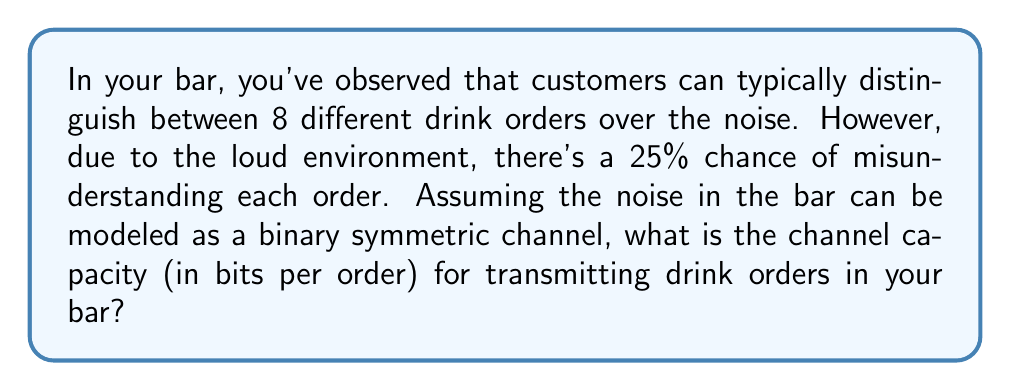Can you answer this question? To solve this problem, we need to use the concept of channel capacity in information theory. Let's break it down step-by-step:

1) First, we need to calculate the entropy of the input. With 8 possible drink orders, assuming they are equally likely, the entropy is:

   $H(X) = \log_2(8) = 3$ bits

2) Next, we need to calculate the noise entropy. In a binary symmetric channel with error probability $p$, the noise entropy is:

   $H(p) = -p\log_2(p) - (1-p)\log_2(1-p)$

   Here, $p = 0.25$

   $H(0.25) = -0.25\log_2(0.25) - 0.75\log_2(0.75) \approx 0.8113$ bits

3) The channel capacity $C$ is given by the maximum of the mutual information $I(X;Y)$:

   $C = \max I(X;Y) = \max [H(Y) - H(Y|X)]$

4) For a binary symmetric channel, this simplifies to:

   $C = 1 - H(p)$

5) Substituting our calculated value:

   $C = 1 - 0.8113 = 0.1887$ bits per use of the channel

6) However, we're transmitting 3 bits per order (as calculated in step 1). So we need to multiply our result by 3:

   $C_{total} = 3 * 0.1887 = 0.5661$ bits per order

Therefore, the channel capacity for transmitting drink orders in your noisy bar environment is approximately 0.5661 bits per order.
Answer: $0.5661$ bits per order 